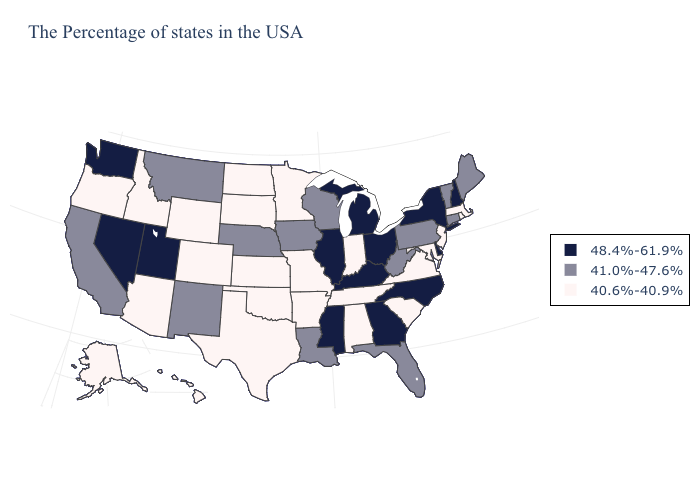Does the map have missing data?
Keep it brief. No. Among the states that border Nevada , which have the lowest value?
Write a very short answer. Arizona, Idaho, Oregon. What is the value of Indiana?
Concise answer only. 40.6%-40.9%. Name the states that have a value in the range 41.0%-47.6%?
Short answer required. Maine, Vermont, Connecticut, Pennsylvania, West Virginia, Florida, Wisconsin, Louisiana, Iowa, Nebraska, New Mexico, Montana, California. Does Iowa have the same value as Delaware?
Keep it brief. No. Does Rhode Island have the lowest value in the Northeast?
Answer briefly. Yes. Does the map have missing data?
Answer briefly. No. Does Virginia have the highest value in the South?
Short answer required. No. Name the states that have a value in the range 48.4%-61.9%?
Write a very short answer. New Hampshire, New York, Delaware, North Carolina, Ohio, Georgia, Michigan, Kentucky, Illinois, Mississippi, Utah, Nevada, Washington. Does Vermont have the highest value in the Northeast?
Give a very brief answer. No. What is the highest value in the West ?
Give a very brief answer. 48.4%-61.9%. Does Rhode Island have the highest value in the Northeast?
Quick response, please. No. What is the value of Oklahoma?
Answer briefly. 40.6%-40.9%. Does Wyoming have the lowest value in the West?
Write a very short answer. Yes. Does Hawaii have a lower value than Wyoming?
Short answer required. No. 